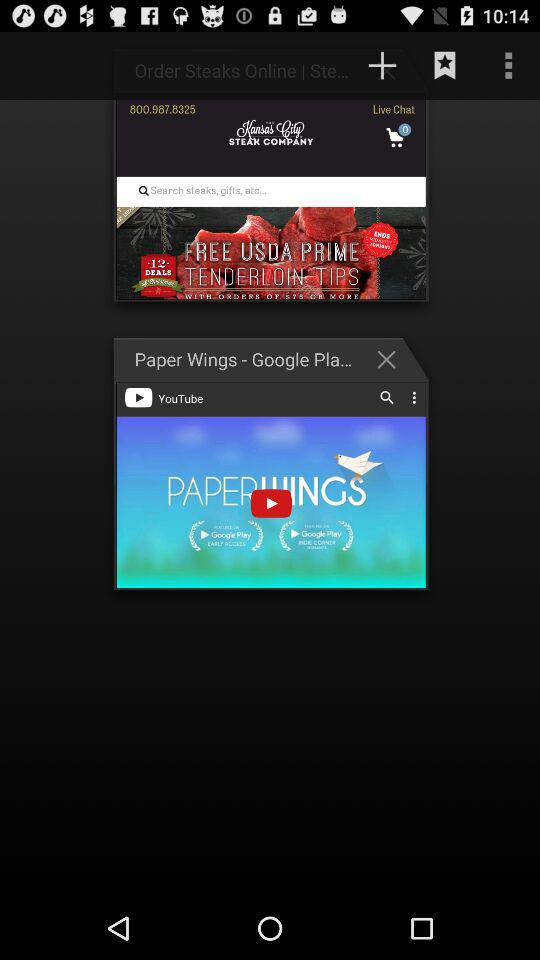How many items are in the cart? There are 0 items in the cart. 